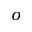<formula> <loc_0><loc_0><loc_500><loc_500>o</formula> 